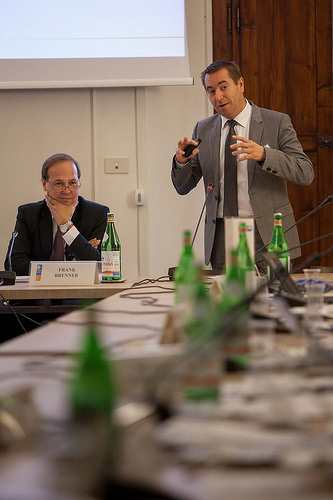<image>
Is the man behind the wall? No. The man is not behind the wall. From this viewpoint, the man appears to be positioned elsewhere in the scene. 